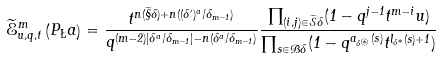<formula> <loc_0><loc_0><loc_500><loc_500>\widetilde { \mathcal { E } } _ { u , q , t } ^ { m } \left ( P _ { \L } a \right ) = \frac { t ^ { n ( \widetilde { \S } \Lambda ) + n ( ( \Lambda ^ { \prime } ) ^ { a } / \delta _ { m - 1 } ) } } { q ^ { ( m - 2 ) | \Lambda ^ { a } / \delta _ { m - 1 } | - n ( \Lambda ^ { a } / \delta _ { m - 1 } ) } } \frac { \prod _ { ( i , j ) \in \widetilde { \mathcal { S } } \Lambda } ( 1 - q ^ { j - 1 } t ^ { m - i } u ) } { \prod _ { s \in \mathcal { B } \Lambda } ( 1 - q ^ { a _ { \Lambda ^ { \circledast } } ( s ) } t ^ { l _ { \Lambda ^ { * } } ( s ) + 1 } ) }</formula> 